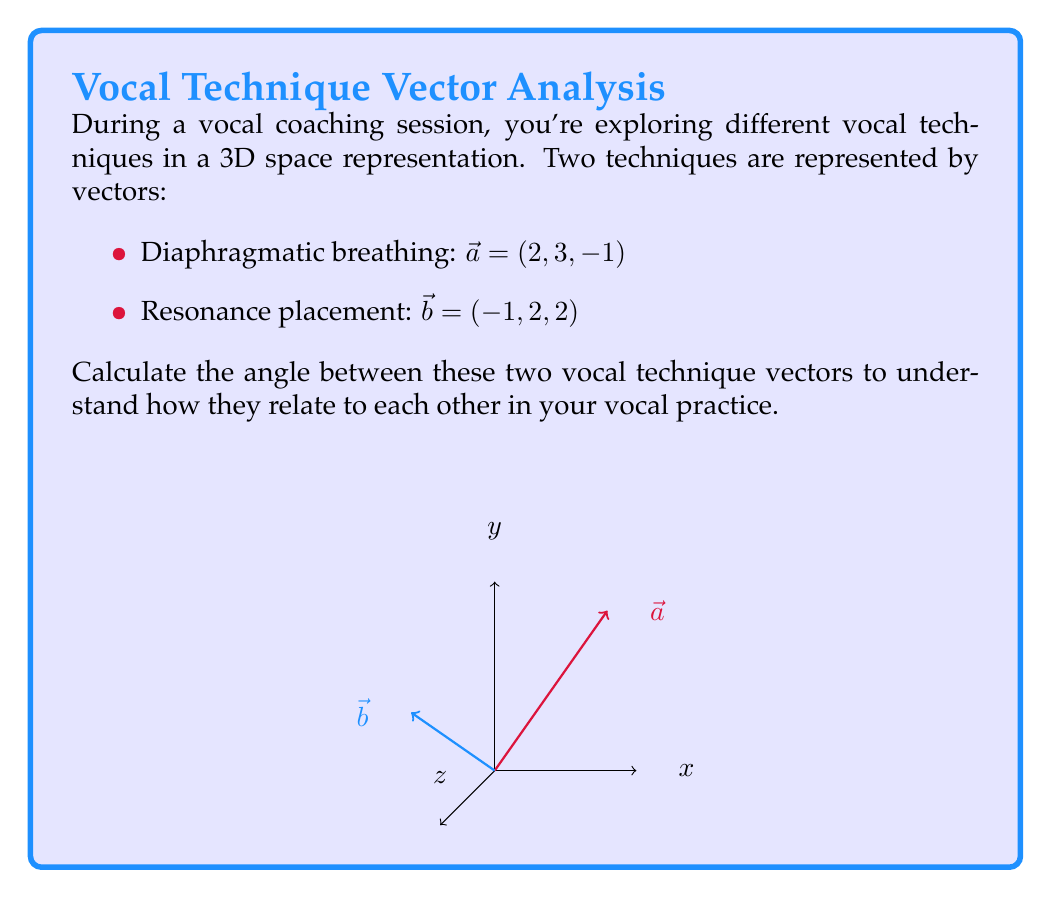Can you solve this math problem? To find the angle between two vectors in 3D space, we can use the dot product formula:

$$\cos \theta = \frac{\vec{a} \cdot \vec{b}}{|\vec{a}||\vec{b}|}$$

Step 1: Calculate the dot product $\vec{a} \cdot \vec{b}$
$$\vec{a} \cdot \vec{b} = (2)(-1) + (3)(2) + (-1)(2) = -2 + 6 - 2 = 2$$

Step 2: Calculate the magnitudes of vectors $\vec{a}$ and $\vec{b}$
$$|\vec{a}| = \sqrt{2^2 + 3^2 + (-1)^2} = \sqrt{4 + 9 + 1} = \sqrt{14}$$
$$|\vec{b}| = \sqrt{(-1)^2 + 2^2 + 2^2} = \sqrt{1 + 4 + 4} = 3$$

Step 3: Apply the dot product formula
$$\cos \theta = \frac{2}{\sqrt{14} \cdot 3} = \frac{2}{3\sqrt{14}}$$

Step 4: Take the inverse cosine (arccos) of both sides
$$\theta = \arccos(\frac{2}{3\sqrt{14}})$$

Step 5: Calculate the final result (in radians)
$$\theta \approx 1.249 \text{ radians}$$

Step 6: Convert to degrees
$$\theta \approx 1.249 \cdot \frac{180}{\pi} \approx 71.57°$$
Answer: $71.57°$ or $1.249 \text{ radians}$ 